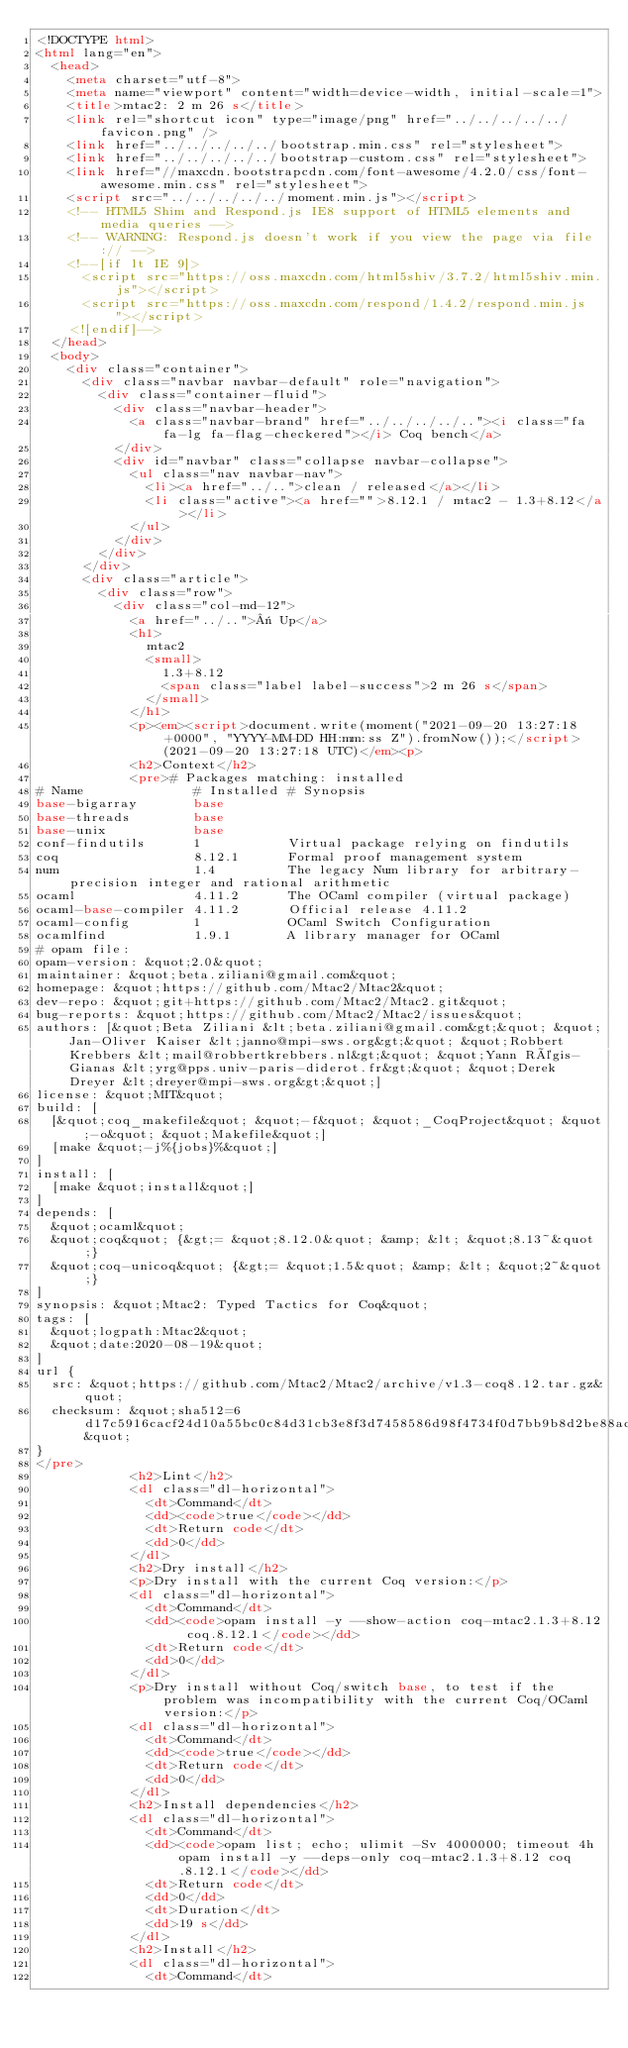<code> <loc_0><loc_0><loc_500><loc_500><_HTML_><!DOCTYPE html>
<html lang="en">
  <head>
    <meta charset="utf-8">
    <meta name="viewport" content="width=device-width, initial-scale=1">
    <title>mtac2: 2 m 26 s</title>
    <link rel="shortcut icon" type="image/png" href="../../../../../favicon.png" />
    <link href="../../../../../bootstrap.min.css" rel="stylesheet">
    <link href="../../../../../bootstrap-custom.css" rel="stylesheet">
    <link href="//maxcdn.bootstrapcdn.com/font-awesome/4.2.0/css/font-awesome.min.css" rel="stylesheet">
    <script src="../../../../../moment.min.js"></script>
    <!-- HTML5 Shim and Respond.js IE8 support of HTML5 elements and media queries -->
    <!-- WARNING: Respond.js doesn't work if you view the page via file:// -->
    <!--[if lt IE 9]>
      <script src="https://oss.maxcdn.com/html5shiv/3.7.2/html5shiv.min.js"></script>
      <script src="https://oss.maxcdn.com/respond/1.4.2/respond.min.js"></script>
    <![endif]-->
  </head>
  <body>
    <div class="container">
      <div class="navbar navbar-default" role="navigation">
        <div class="container-fluid">
          <div class="navbar-header">
            <a class="navbar-brand" href="../../../../.."><i class="fa fa-lg fa-flag-checkered"></i> Coq bench</a>
          </div>
          <div id="navbar" class="collapse navbar-collapse">
            <ul class="nav navbar-nav">
              <li><a href="../..">clean / released</a></li>
              <li class="active"><a href="">8.12.1 / mtac2 - 1.3+8.12</a></li>
            </ul>
          </div>
        </div>
      </div>
      <div class="article">
        <div class="row">
          <div class="col-md-12">
            <a href="../..">« Up</a>
            <h1>
              mtac2
              <small>
                1.3+8.12
                <span class="label label-success">2 m 26 s</span>
              </small>
            </h1>
            <p><em><script>document.write(moment("2021-09-20 13:27:18 +0000", "YYYY-MM-DD HH:mm:ss Z").fromNow());</script> (2021-09-20 13:27:18 UTC)</em><p>
            <h2>Context</h2>
            <pre># Packages matching: installed
# Name              # Installed # Synopsis
base-bigarray       base
base-threads        base
base-unix           base
conf-findutils      1           Virtual package relying on findutils
coq                 8.12.1      Formal proof management system
num                 1.4         The legacy Num library for arbitrary-precision integer and rational arithmetic
ocaml               4.11.2      The OCaml compiler (virtual package)
ocaml-base-compiler 4.11.2      Official release 4.11.2
ocaml-config        1           OCaml Switch Configuration
ocamlfind           1.9.1       A library manager for OCaml
# opam file:
opam-version: &quot;2.0&quot;
maintainer: &quot;beta.ziliani@gmail.com&quot;
homepage: &quot;https://github.com/Mtac2/Mtac2&quot;
dev-repo: &quot;git+https://github.com/Mtac2/Mtac2.git&quot;
bug-reports: &quot;https://github.com/Mtac2/Mtac2/issues&quot;
authors: [&quot;Beta Ziliani &lt;beta.ziliani@gmail.com&gt;&quot; &quot;Jan-Oliver Kaiser &lt;janno@mpi-sws.org&gt;&quot; &quot;Robbert Krebbers &lt;mail@robbertkrebbers.nl&gt;&quot; &quot;Yann Régis-Gianas &lt;yrg@pps.univ-paris-diderot.fr&gt;&quot; &quot;Derek Dreyer &lt;dreyer@mpi-sws.org&gt;&quot;]
license: &quot;MIT&quot;
build: [
  [&quot;coq_makefile&quot; &quot;-f&quot; &quot;_CoqProject&quot; &quot;-o&quot; &quot;Makefile&quot;]
  [make &quot;-j%{jobs}%&quot;]
]
install: [
  [make &quot;install&quot;]
]
depends: [
  &quot;ocaml&quot;
  &quot;coq&quot; {&gt;= &quot;8.12.0&quot; &amp; &lt; &quot;8.13~&quot;}
  &quot;coq-unicoq&quot; {&gt;= &quot;1.5&quot; &amp; &lt; &quot;2~&quot;}
]
synopsis: &quot;Mtac2: Typed Tactics for Coq&quot;
tags: [
  &quot;logpath:Mtac2&quot;
  &quot;date:2020-08-19&quot;
]
url {
  src: &quot;https://github.com/Mtac2/Mtac2/archive/v1.3-coq8.12.tar.gz&quot;
  checksum: &quot;sha512=6d17c5916cacf24d10a55bc0c84d31cb3e8f3d7458586d98f4734f0d7bb9b8d2be88ada15537aaada478a9f844692f5d271f8b7e721743c70272fa44ffd47ac8&quot;
}
</pre>
            <h2>Lint</h2>
            <dl class="dl-horizontal">
              <dt>Command</dt>
              <dd><code>true</code></dd>
              <dt>Return code</dt>
              <dd>0</dd>
            </dl>
            <h2>Dry install</h2>
            <p>Dry install with the current Coq version:</p>
            <dl class="dl-horizontal">
              <dt>Command</dt>
              <dd><code>opam install -y --show-action coq-mtac2.1.3+8.12 coq.8.12.1</code></dd>
              <dt>Return code</dt>
              <dd>0</dd>
            </dl>
            <p>Dry install without Coq/switch base, to test if the problem was incompatibility with the current Coq/OCaml version:</p>
            <dl class="dl-horizontal">
              <dt>Command</dt>
              <dd><code>true</code></dd>
              <dt>Return code</dt>
              <dd>0</dd>
            </dl>
            <h2>Install dependencies</h2>
            <dl class="dl-horizontal">
              <dt>Command</dt>
              <dd><code>opam list; echo; ulimit -Sv 4000000; timeout 4h opam install -y --deps-only coq-mtac2.1.3+8.12 coq.8.12.1</code></dd>
              <dt>Return code</dt>
              <dd>0</dd>
              <dt>Duration</dt>
              <dd>19 s</dd>
            </dl>
            <h2>Install</h2>
            <dl class="dl-horizontal">
              <dt>Command</dt></code> 